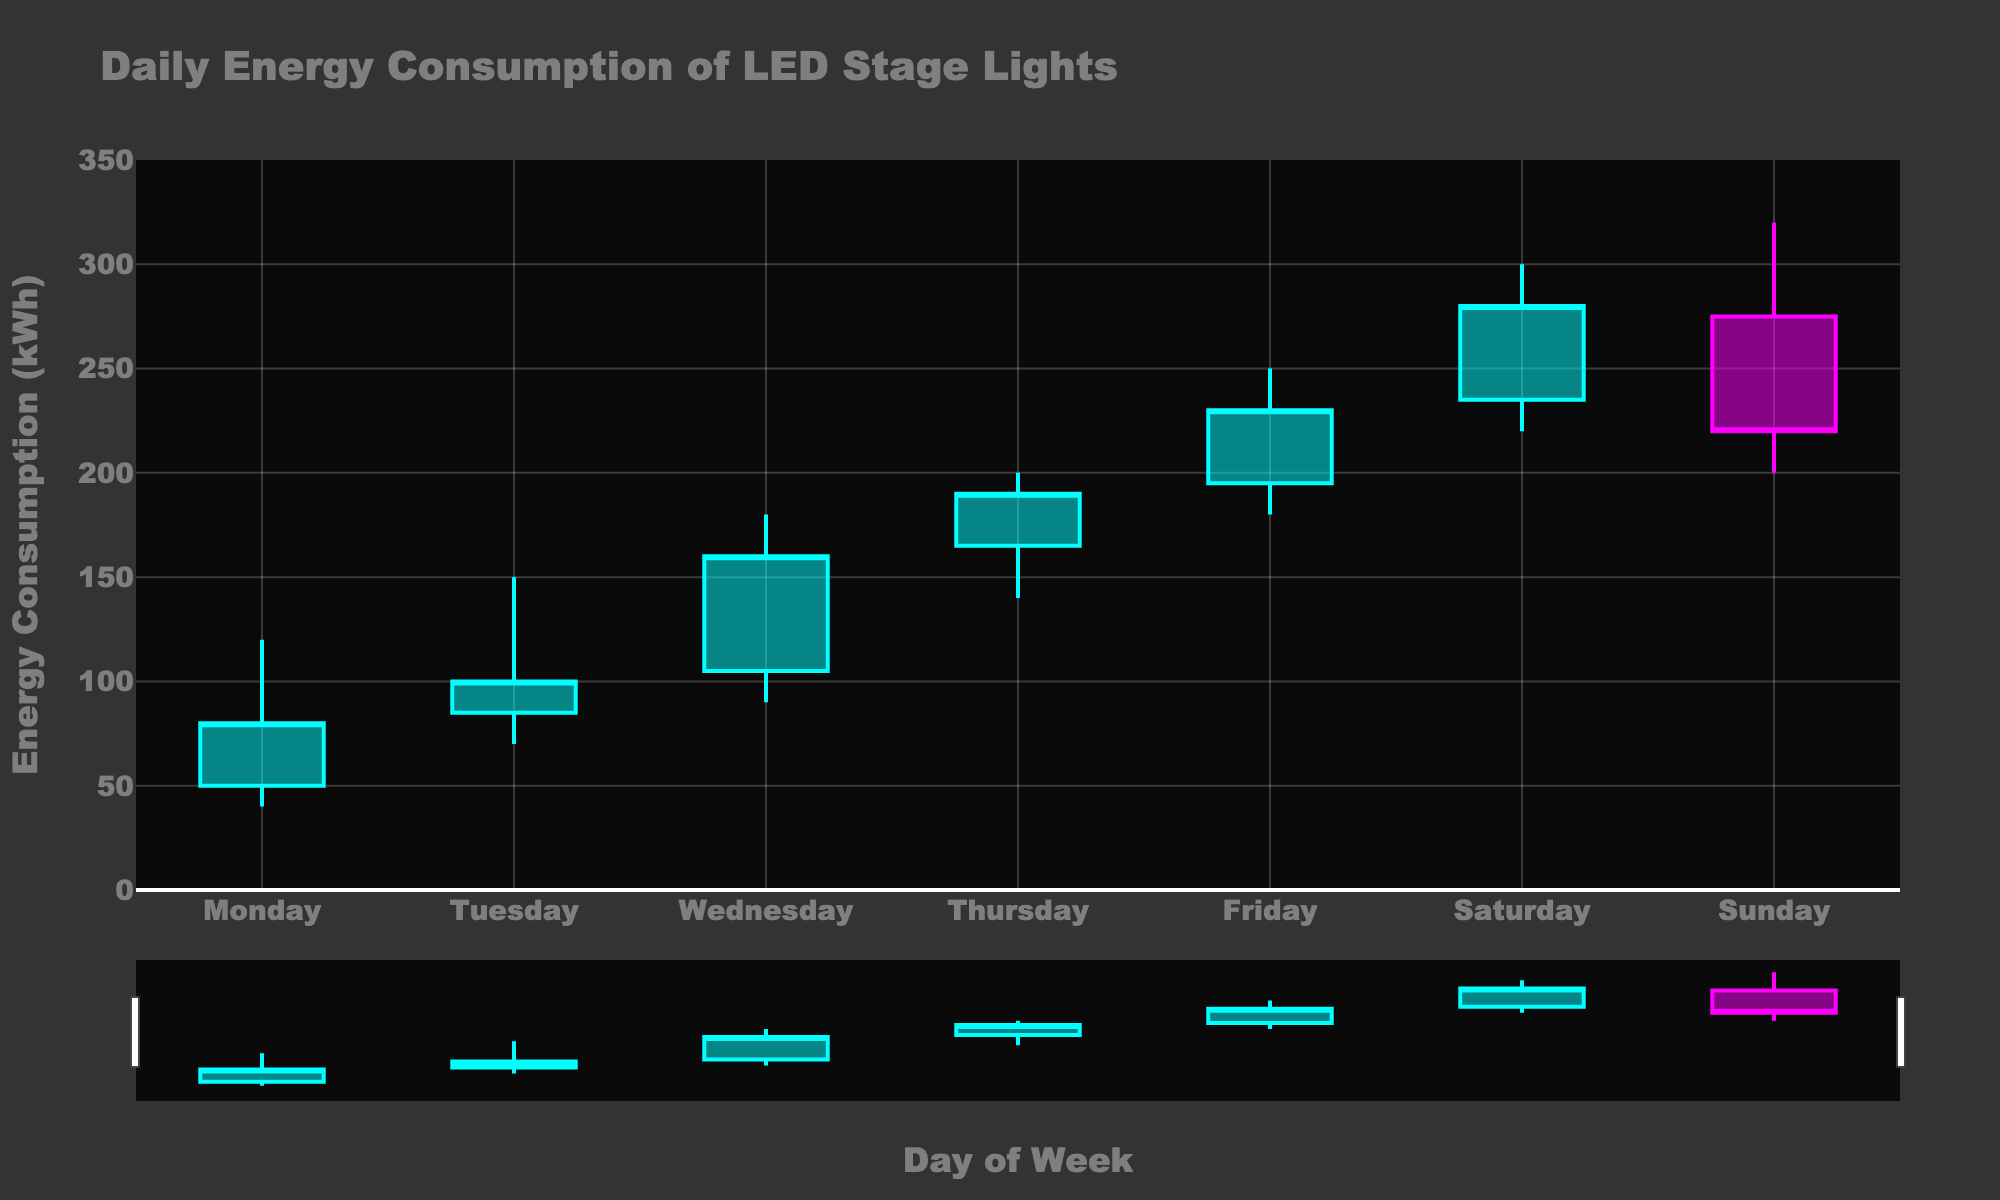What is the title of this figure? The title is usually prominently displayed at the top of the figure. Here, it reads "Daily Energy Consumption of LED Stage Lights."
Answer: Daily Energy Consumption of LED Stage Lights What is the y-axis title of the chart? The y-axis title is displayed along the vertical y-axis, indicating what the measurements represent. In this figure, the y-axis title is "Energy Consumption (kWh)."
Answer: Energy Consumption (kWh) Which day shows the highest energy consumption in the high range? To find the highest energy consumption in the high range, look at the "High" values for each day. The highest value is 320 on Sunday.
Answer: Sunday How many days have a closing value that is higher than the opening value? Compare the opening and closing values for each day. If the closing value is higher, then count that day. The days with higher closing values than opening are Tuesday, Wednesday, Thursday, Friday, and Saturday, which adds up to five days.
Answer: 5 Which day had the smallest range between its low and high values? Calculate the range for each day by subtracting the low value from the high value. For Monday, it's 120 - 40 = 80, and for other days, it's similarly calculated. The smallest range, 100 (320 - 220), occurs on Sunday.
Answer: Sunday What is the difference in closing values between Friday and Saturday? Look at the closing values for Friday and Saturday, which are 230 and 280, respectively. The difference is 280 - 230 = 50 kWh.
Answer: 50 kWh On which day does the highest visible decrease in energy consumption occur? Identify the days where the opening value is higher than the closing value, and then find the largest difference. On Sunday, the opening value is 275, and the closing value is 220, resulting in a 55 kWh drop.
Answer: Sunday Which color represents increasing energy consumption in the chart? The chart uses legends to differentiate, and lighter cyan represents an increase while magenta (light violet) represents a decrease. The increasing line and fill are cyan.
Answer: Cyan What is the average opening energy consumption for the week? Sum all the opening values: 50 + 85 + 105 + 165 + 195 + 235 + 275, which equals 1110 kWh. Divide by 7 days to get 1110 / 7 = 158.57 kWh.
Answer: 158.57 kWh 